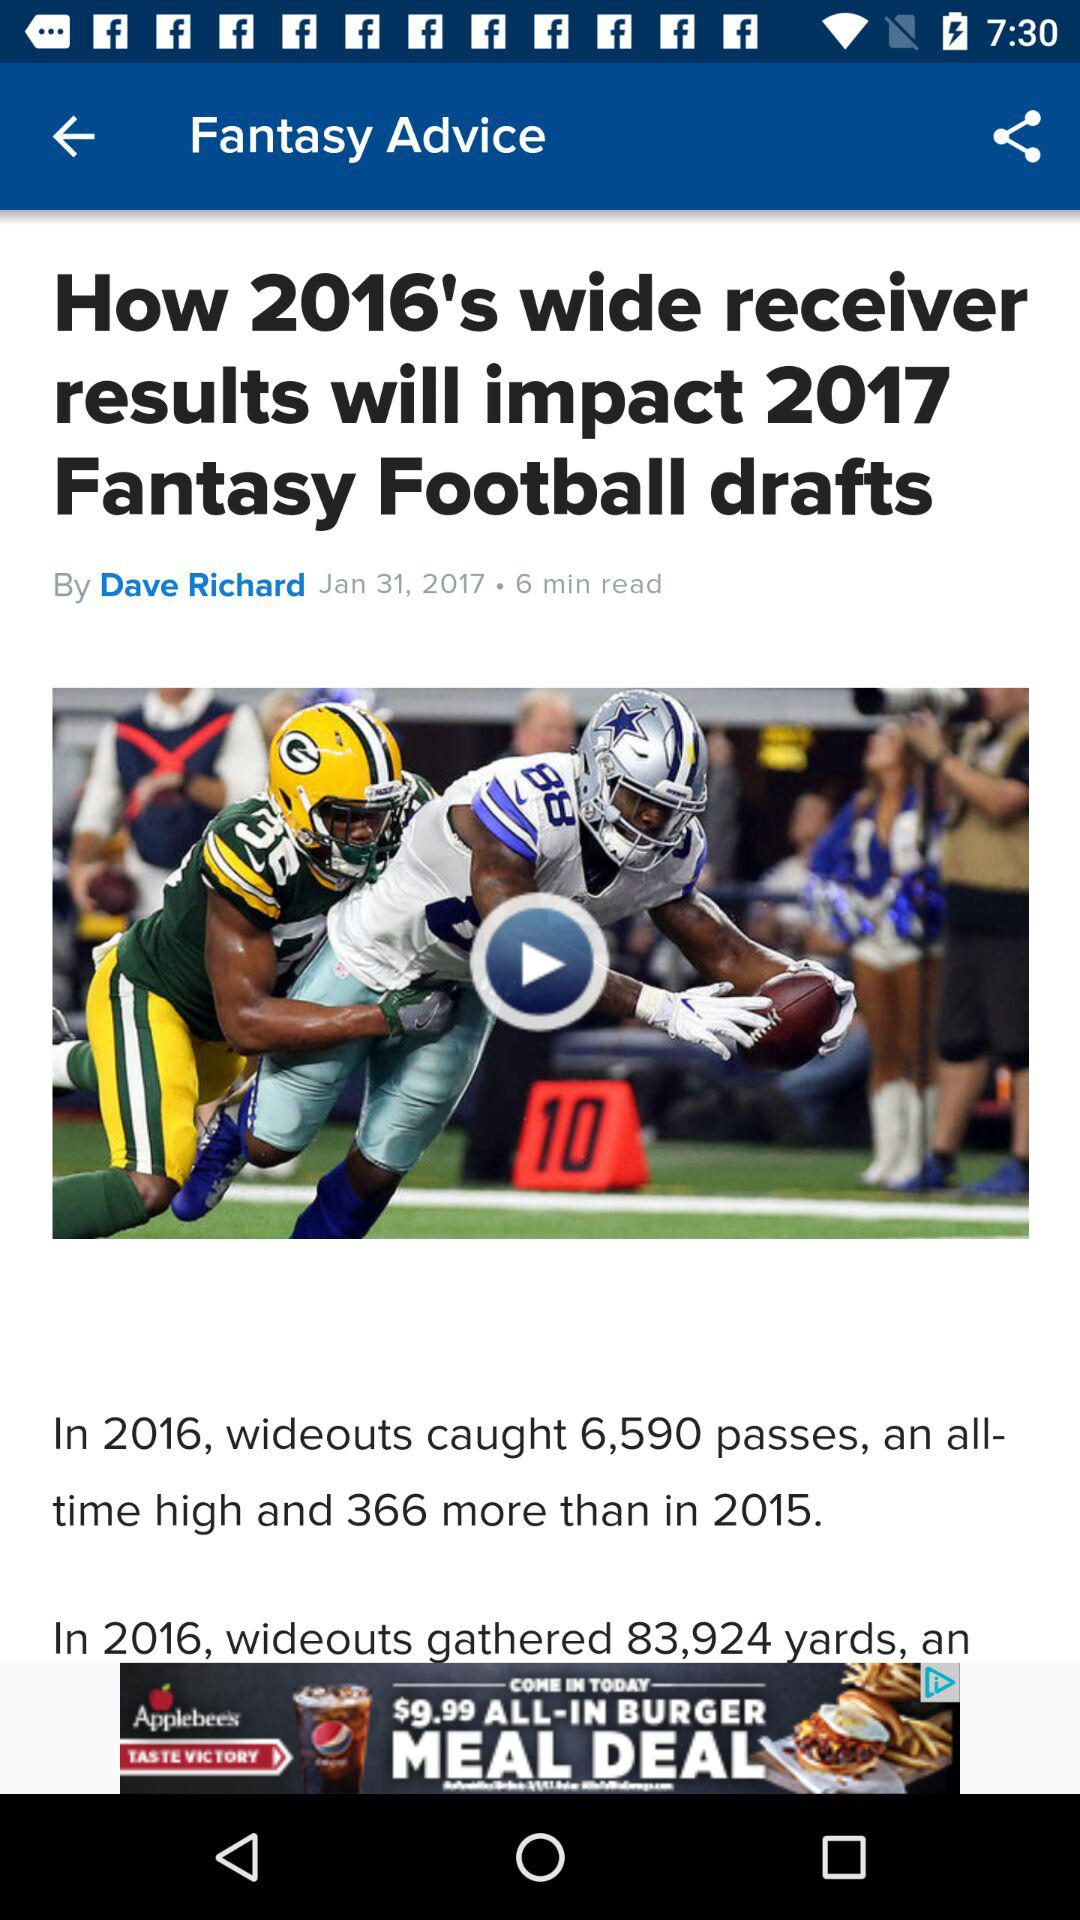How many more passes were caught in 2016 than 2015?
Answer the question using a single word or phrase. 366 